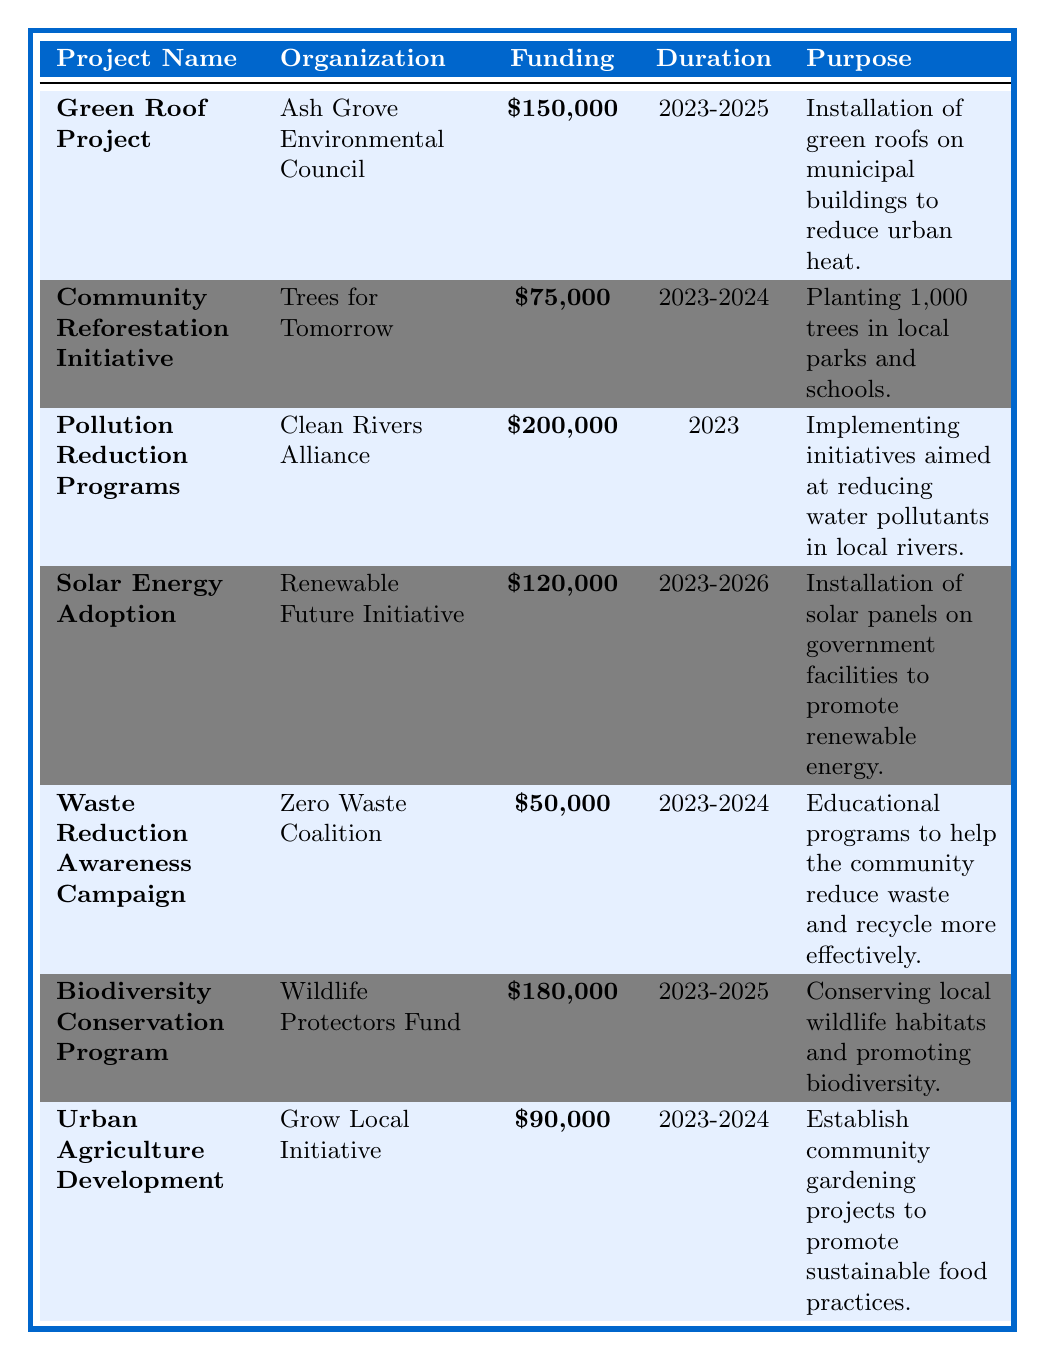What is the total funding amount allocated to the Biodiversity Conservation Program? The funding amount for the Biodiversity Conservation Program is clearly stated in the table as $180,000.
Answer: $180,000 Which organization is responsible for the Community Reforestation Initiative? The organization listed next to the Community Reforestation Initiative in the table is Trees for Tomorrow.
Answer: Trees for Tomorrow How many years is the Solar Energy Adoption project funded for? The duration of the Solar Energy Adoption project is indicated as 2023-2026, which is a total of 4 years.
Answer: 4 years What is the purpose of the Pollution Reduction Programs? The purpose of the Pollution Reduction Programs is summarized in the table as implementing initiatives aimed at reducing water pollutants in local rivers.
Answer: Reducing water pollutants in local rivers Which project has the highest funding amount, and how much is it funded for? By comparing the funding amounts, the project with the highest funding is the Pollution Reduction Programs with $200,000.
Answer: Pollution Reduction Programs, $200,000 How much funding is allocated to initiatives designed for waste reduction? The Waste Reduction Awareness Campaign has a funding amount listed as $50,000.
Answer: $50,000 Are there any projects aimed at promoting solar energy adoption? Yes, the Solar Energy Adoption project is specifically designed to install solar panels on government facilities.
Answer: Yes What is the combined funding amount of the Urban Agriculture Development and Community Reforestation Initiative projects? The funding amounts for these projects are $90,000 for Urban Agriculture Development and $75,000 for Community Reforestation Initiative. Adding these together gives $90,000 + $75,000 = $165,000.
Answer: $165,000 Is the Green Roof Project set to last longer than the Community Reforestation Initiative? Yes, the Green Roof Project is set to last from 2023 to 2025 (2 years), while the Community Reforestation Initiative lasts from 2023 to 2024 (1 year).
Answer: Yes How many total projects are funded in the year 2023? There are 4 projects listed with a duration that includes the year 2023, namely the Green Roof Project, Pollution Reduction Programs, Solar Energy Adoption, and Waste Reduction Awareness Campaign.
Answer: 4 projects 